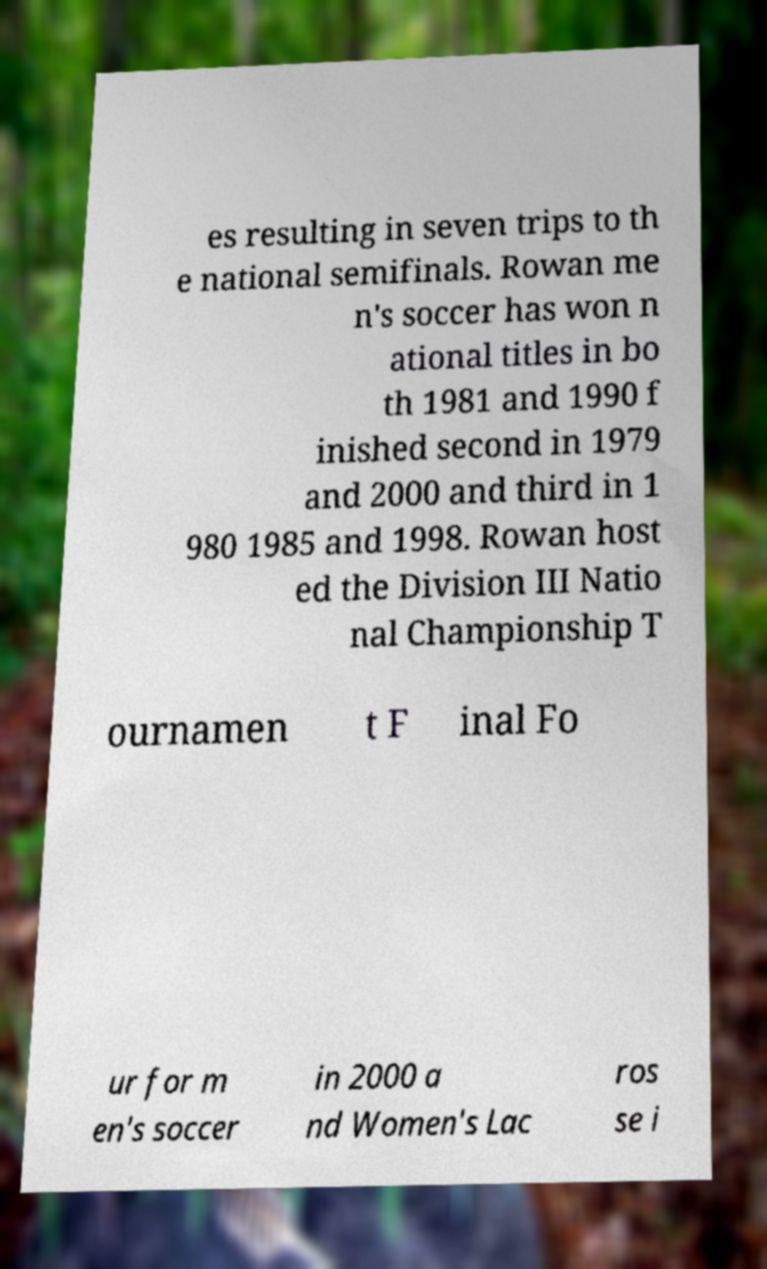Please read and relay the text visible in this image. What does it say? es resulting in seven trips to th e national semifinals. Rowan me n's soccer has won n ational titles in bo th 1981 and 1990 f inished second in 1979 and 2000 and third in 1 980 1985 and 1998. Rowan host ed the Division III Natio nal Championship T ournamen t F inal Fo ur for m en's soccer in 2000 a nd Women's Lac ros se i 